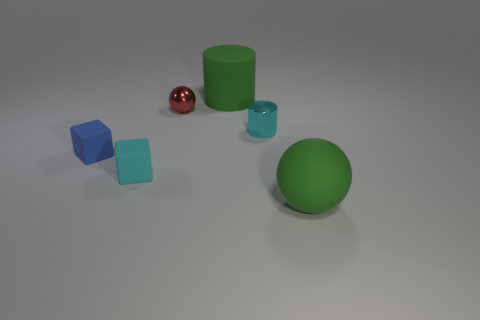What number of cyan blocks are the same size as the green rubber ball?
Offer a terse response. 0. Does the green cylinder have the same size as the shiny thing left of the small cyan cylinder?
Provide a short and direct response. No. How many objects are either red metal spheres or green rubber balls?
Offer a very short reply. 2. How many big rubber spheres have the same color as the large rubber cylinder?
Make the answer very short. 1. The blue object that is the same size as the cyan matte thing is what shape?
Offer a terse response. Cube. Is there a cyan metallic thing that has the same shape as the tiny blue thing?
Ensure brevity in your answer.  No. How many other objects are made of the same material as the small red object?
Keep it short and to the point. 1. Does the ball on the left side of the large matte cylinder have the same material as the cyan cylinder?
Your response must be concise. Yes. Is the number of objects behind the tiny red metal ball greater than the number of small cyan matte cubes behind the tiny cyan metallic thing?
Provide a short and direct response. Yes. There is a red ball that is the same size as the cyan matte thing; what material is it?
Give a very brief answer. Metal. 